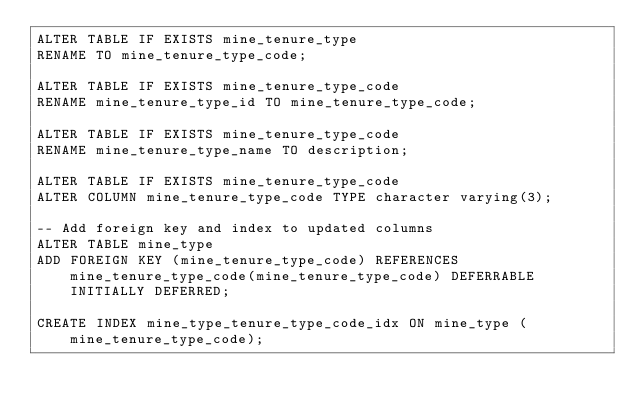<code> <loc_0><loc_0><loc_500><loc_500><_SQL_>ALTER TABLE IF EXISTS mine_tenure_type
RENAME TO mine_tenure_type_code;

ALTER TABLE IF EXISTS mine_tenure_type_code
RENAME mine_tenure_type_id TO mine_tenure_type_code;

ALTER TABLE IF EXISTS mine_tenure_type_code
RENAME mine_tenure_type_name TO description;

ALTER TABLE IF EXISTS mine_tenure_type_code
ALTER COLUMN mine_tenure_type_code TYPE character varying(3);

-- Add foreign key and index to updated columns
ALTER TABLE mine_type
ADD FOREIGN KEY (mine_tenure_type_code) REFERENCES mine_tenure_type_code(mine_tenure_type_code) DEFERRABLE INITIALLY DEFERRED;

CREATE INDEX mine_type_tenure_type_code_idx ON mine_type (mine_tenure_type_code);
</code> 